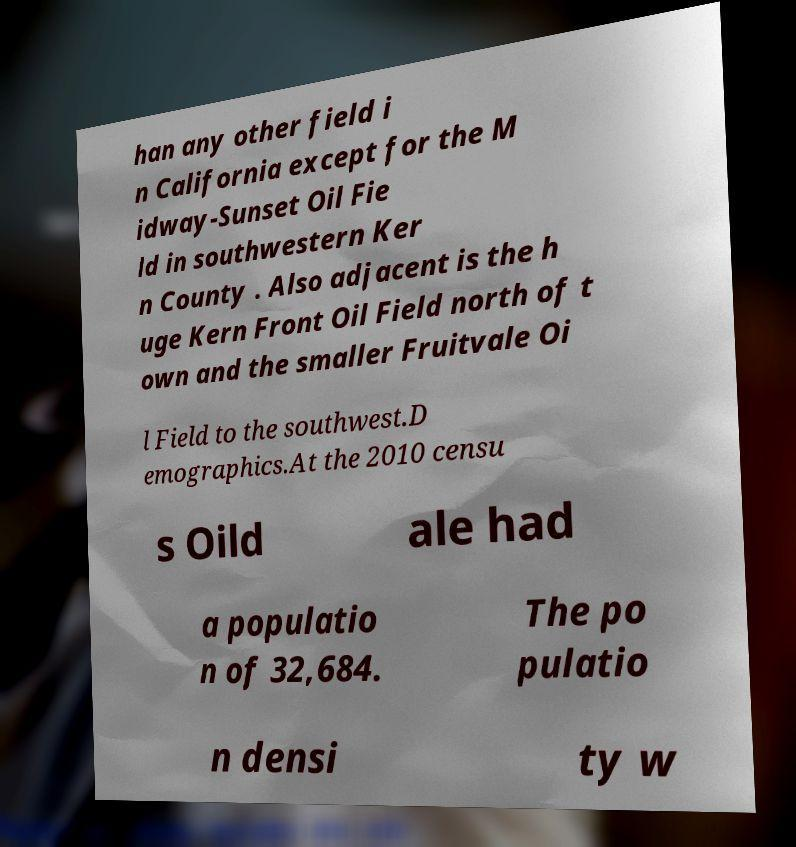Can you read and provide the text displayed in the image?This photo seems to have some interesting text. Can you extract and type it out for me? han any other field i n California except for the M idway-Sunset Oil Fie ld in southwestern Ker n County . Also adjacent is the h uge Kern Front Oil Field north of t own and the smaller Fruitvale Oi l Field to the southwest.D emographics.At the 2010 censu s Oild ale had a populatio n of 32,684. The po pulatio n densi ty w 